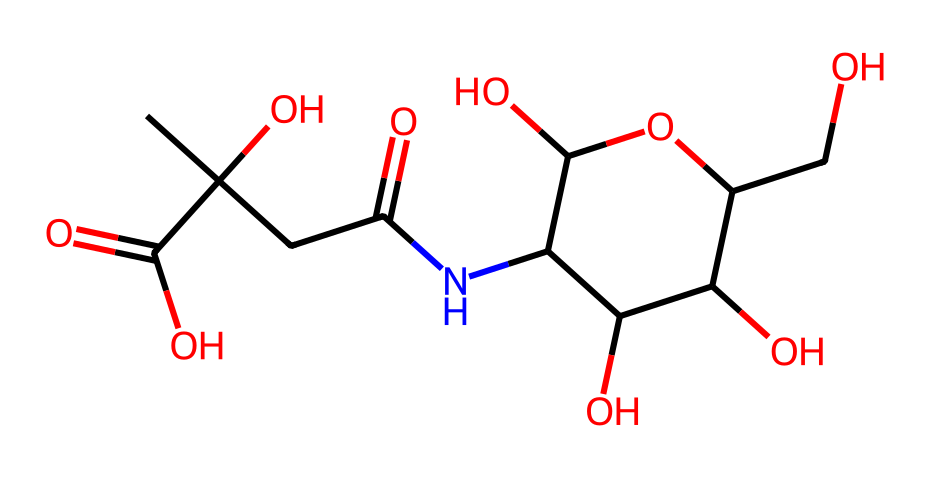how many carbon atoms are present in this chemical? By analyzing the chemical structure, we can count the number of carbon atoms. Each carbon (C) in the SMILES representation corresponds to a "C" symbol; summing them gives us the total.
Answer: eight what is the primary functional group present in this molecule? The structure has multiple functional groups, but the dominant one is the carboxyl group (—COOH). This can be identified by the presence of the double bond to oxygen and the hydroxyl group adjacent to it.
Answer: carboxyl which molecule serves as the backbone in this structure? The backbone in many molecules is composed of carbon atoms, but in this case, the cyclic part containing nitrogen and oxygen can be identified as a ring structure that provides stability and functionality.
Answer: ring structure how many hydroxyl groups are found in this chemical? Hydroxyl groups are represented by the —OH notation in the molecule. Counting each —OH group as it appears in the SMILES tells us the total number present.
Answer: four does this molecule contain any amine groups? Analyzing the chemical structure, we look for nitrogen atoms that are bonded to carbon atoms without the -COOH or NH3 groups. Since there is a nitrogen atom not in those situations, it's considered an amine.
Answer: yes what role does this molecule play in skin care products? Hyaluronic acid is known primarily for its ability to retain moisture, keeping skin hydrated by attracting water molecules to itself. This property is crucial for maintaining skin elasticity and softness.
Answer: moisturizer 